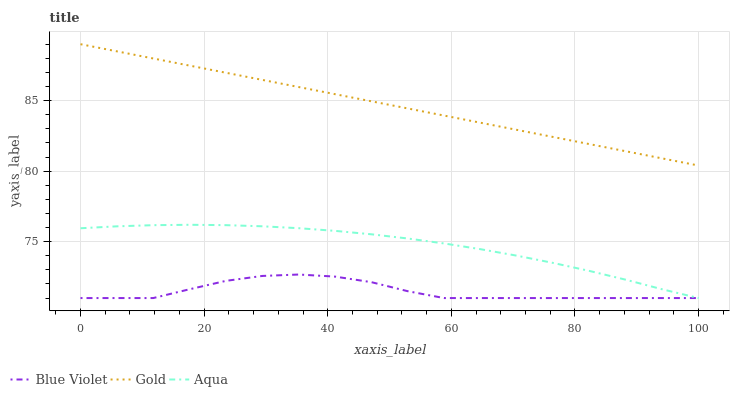Does Blue Violet have the minimum area under the curve?
Answer yes or no. Yes. Does Gold have the maximum area under the curve?
Answer yes or no. Yes. Does Gold have the minimum area under the curve?
Answer yes or no. No. Does Blue Violet have the maximum area under the curve?
Answer yes or no. No. Is Gold the smoothest?
Answer yes or no. Yes. Is Blue Violet the roughest?
Answer yes or no. Yes. Is Blue Violet the smoothest?
Answer yes or no. No. Is Gold the roughest?
Answer yes or no. No. Does Gold have the lowest value?
Answer yes or no. No. Does Gold have the highest value?
Answer yes or no. Yes. Does Blue Violet have the highest value?
Answer yes or no. No. Is Blue Violet less than Gold?
Answer yes or no. Yes. Is Gold greater than Blue Violet?
Answer yes or no. Yes. Does Blue Violet intersect Gold?
Answer yes or no. No. 